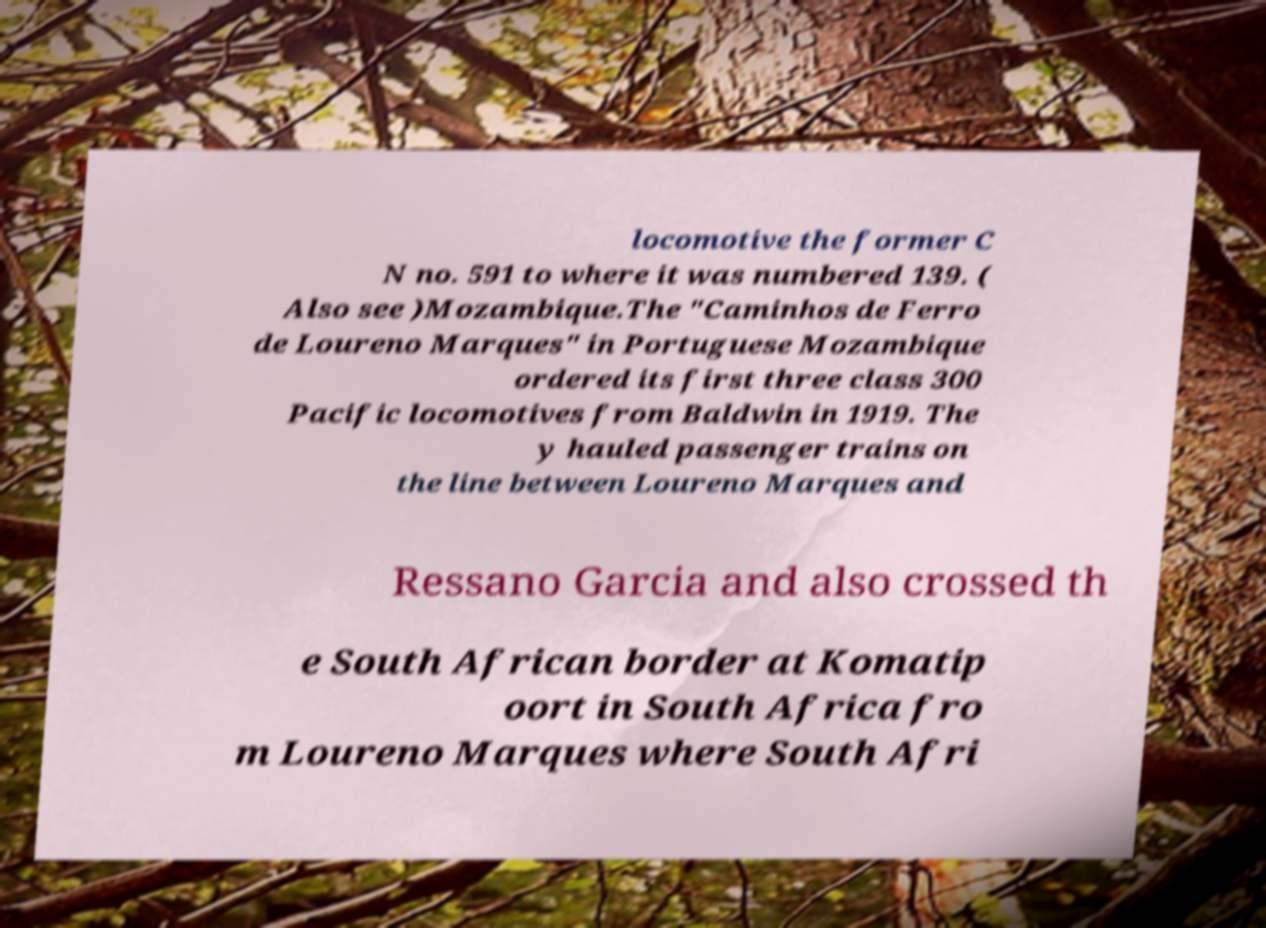I need the written content from this picture converted into text. Can you do that? locomotive the former C N no. 591 to where it was numbered 139. ( Also see )Mozambique.The "Caminhos de Ferro de Loureno Marques" in Portuguese Mozambique ordered its first three class 300 Pacific locomotives from Baldwin in 1919. The y hauled passenger trains on the line between Loureno Marques and Ressano Garcia and also crossed th e South African border at Komatip oort in South Africa fro m Loureno Marques where South Afri 